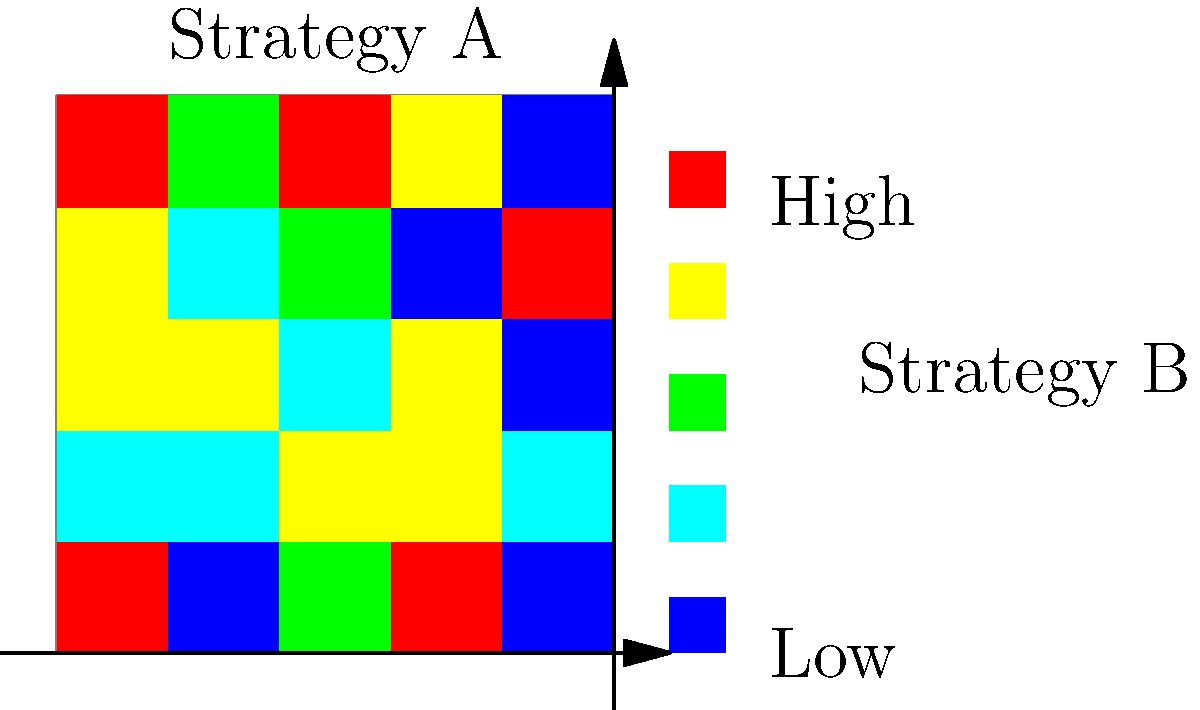Based on the heat map overlay of two different patrol strategies in a 5x5 city grid, which strategy appears to be more effective in reducing crime rates across the entire city? Justify your answer using the color intensity distribution shown in the map. To analyze the effectiveness of the two patrol strategies, we need to consider the following steps:

1. Interpret the heat map:
   - Blue/green colors represent lower crime rates
   - Yellow/red colors represent higher crime rates

2. Analyze Strategy A (top grid):
   - Observe the distribution of colors
   - Note any patterns or clusters of high/low intensity

3. Analyze Strategy B (bottom grid):
   - Observe the distribution of colors
   - Note any patterns or clusters of high/low intensity

4. Compare the two strategies:
   - Look at the overall color distribution
   - Consider the number of high-intensity (red/yellow) and low-intensity (blue/green) areas

5. Evaluate citywide effectiveness:
   - Determine which strategy has a more even distribution of low-intensity areas
   - Consider which strategy better addresses potential crime hotspots

6. Make a conclusion:
   - Based on the analysis, Strategy B appears more effective
   - It shows a more even distribution of cooler colors (blue/green)
   - There are fewer high-intensity (red/yellow) areas compared to Strategy A

7. Consider the implications:
   - Strategy B likely provides better overall coverage of the city
   - It may be more successful in preventing crime across different areas
   - Strategy A seems to have more concentrated patrols, leaving some areas potentially underserved
Answer: Strategy B is more effective due to its more even distribution of lower crime rates (cooler colors) across the city grid. 